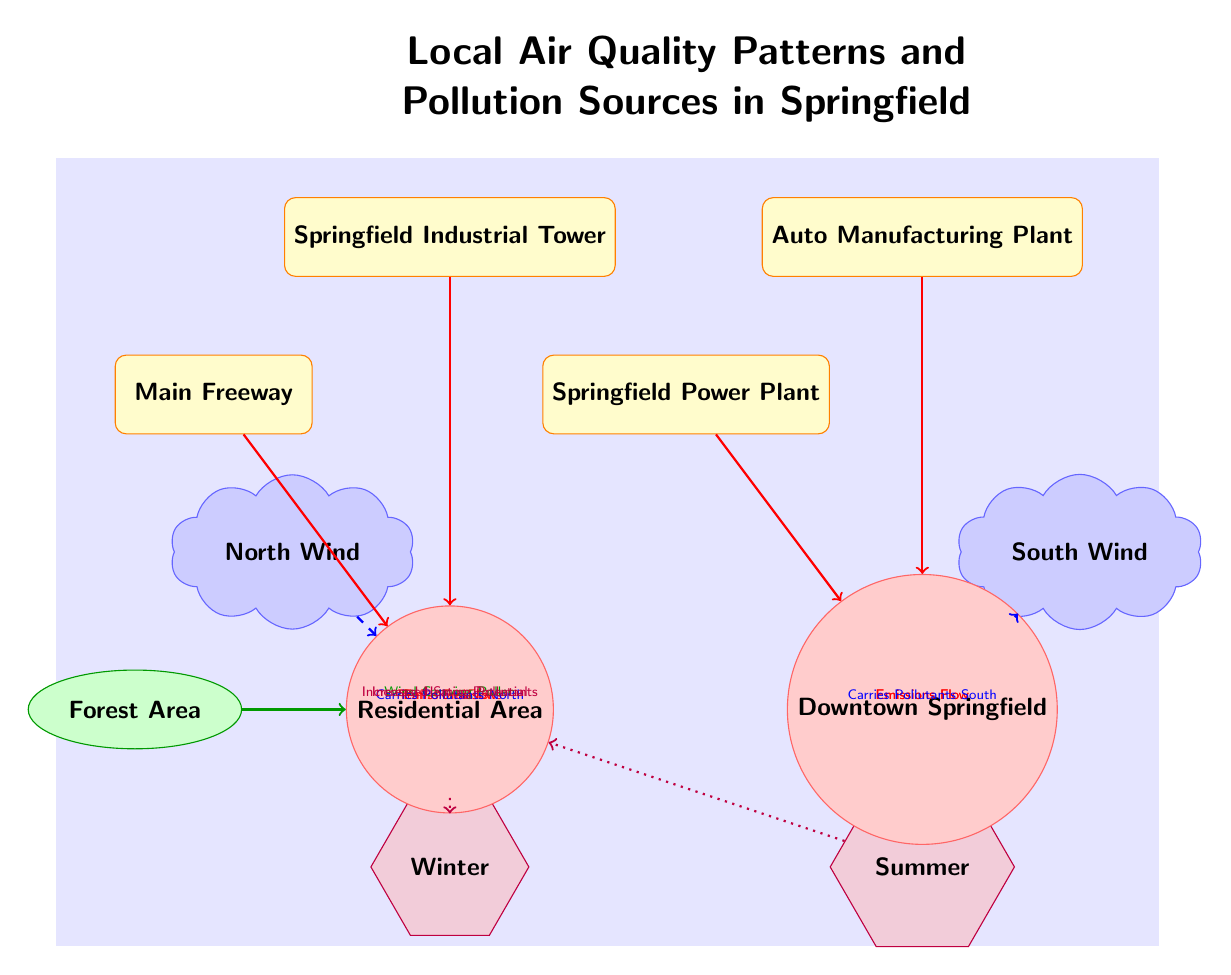What are the main pollution sources depicted in the diagram? The diagram identifies four main pollution sources: Springfield Industrial Tower, Auto Manufacturing Plant, Springfield Power Plant, and Main Freeway.
Answer: Springfield Industrial Tower, Auto Manufacturing Plant, Springfield Power Plant, Main Freeway How many destinations are shown in the diagram? There are two destinations represented in the diagram: Residential Area and Downtown Springfield.
Answer: 2 Which natural source is indicated in the diagram? The diagram shows Forest Area as the natural source affecting air quality.
Answer: Forest Area What effect does North Wind have on the Residential Area? The North Wind carries pollutants towards the Residential Area, as indicated by the directional flow.
Answer: Carries Pollutants North Which season is associated with increased heating pollutants in the Residential Area? The diagram shows Winter as the season associated with increased heating pollutants in the Residential Area.
Answer: Winter How do pollutants from the Auto Manufacturing Plant disperse according to the diagram? Pollutants from the Auto Manufacturing Plant flow directly to Downtown Springfield, indicating the primary path of dispersion.
Answer: Emissions Flow During which season is there increased smog potential noted in the diagram? The diagram indicates Summer as the season associated with increased smog potential.
Answer: Summer What type of pollutant is carried by wind from the Forest Area to the Residential Area? The wind carries pollen from the Forest Area to the Residential Area, as illustrated in the diagram.
Answer: Wind Carrying Pollen How many wind patterns are represented in the diagram? The diagram depicts two wind patterns: North Wind and South Wind.
Answer: 2 